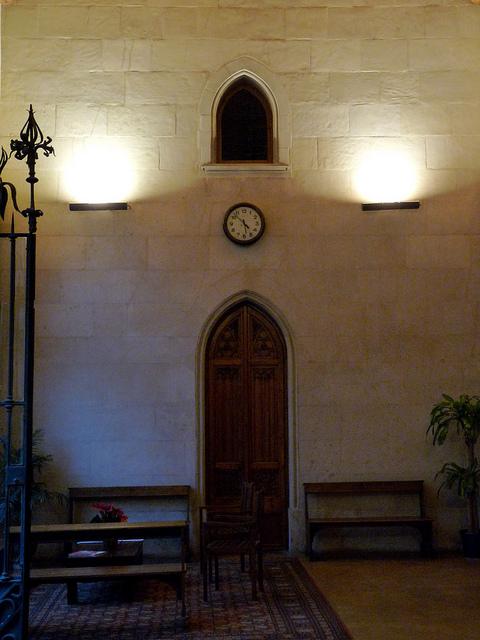What time does the clock say?
Keep it brief. 5:53. How many lights are there?
Keep it brief. 2. Are the lights on?
Be succinct. Yes. What time does the clock read?
Short answer required. 4:30. Is this a hotel room?
Give a very brief answer. No. 